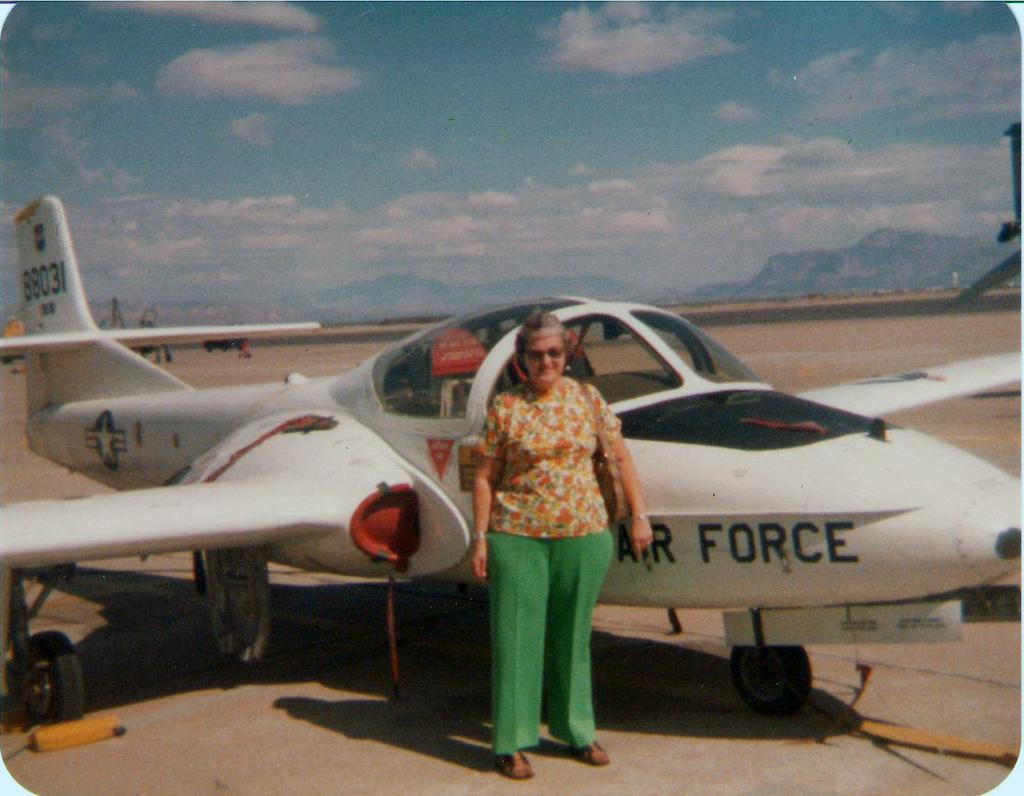<image>
Summarize the visual content of the image. A woman standing next to an Air Force plane outside. 